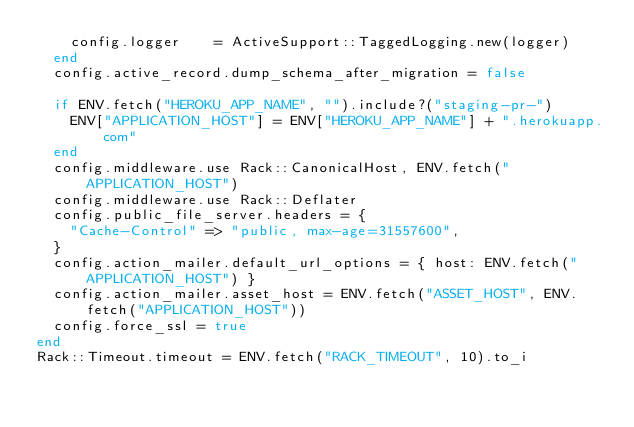Convert code to text. <code><loc_0><loc_0><loc_500><loc_500><_Ruby_>    config.logger    = ActiveSupport::TaggedLogging.new(logger)
  end
  config.active_record.dump_schema_after_migration = false
  
  if ENV.fetch("HEROKU_APP_NAME", "").include?("staging-pr-")
    ENV["APPLICATION_HOST"] = ENV["HEROKU_APP_NAME"] + ".herokuapp.com"
  end
  config.middleware.use Rack::CanonicalHost, ENV.fetch("APPLICATION_HOST")
  config.middleware.use Rack::Deflater
  config.public_file_server.headers = {
    "Cache-Control" => "public, max-age=31557600",
  }
  config.action_mailer.default_url_options = { host: ENV.fetch("APPLICATION_HOST") }
  config.action_mailer.asset_host = ENV.fetch("ASSET_HOST", ENV.fetch("APPLICATION_HOST"))
  config.force_ssl = true
end
Rack::Timeout.timeout = ENV.fetch("RACK_TIMEOUT", 10).to_i</code> 